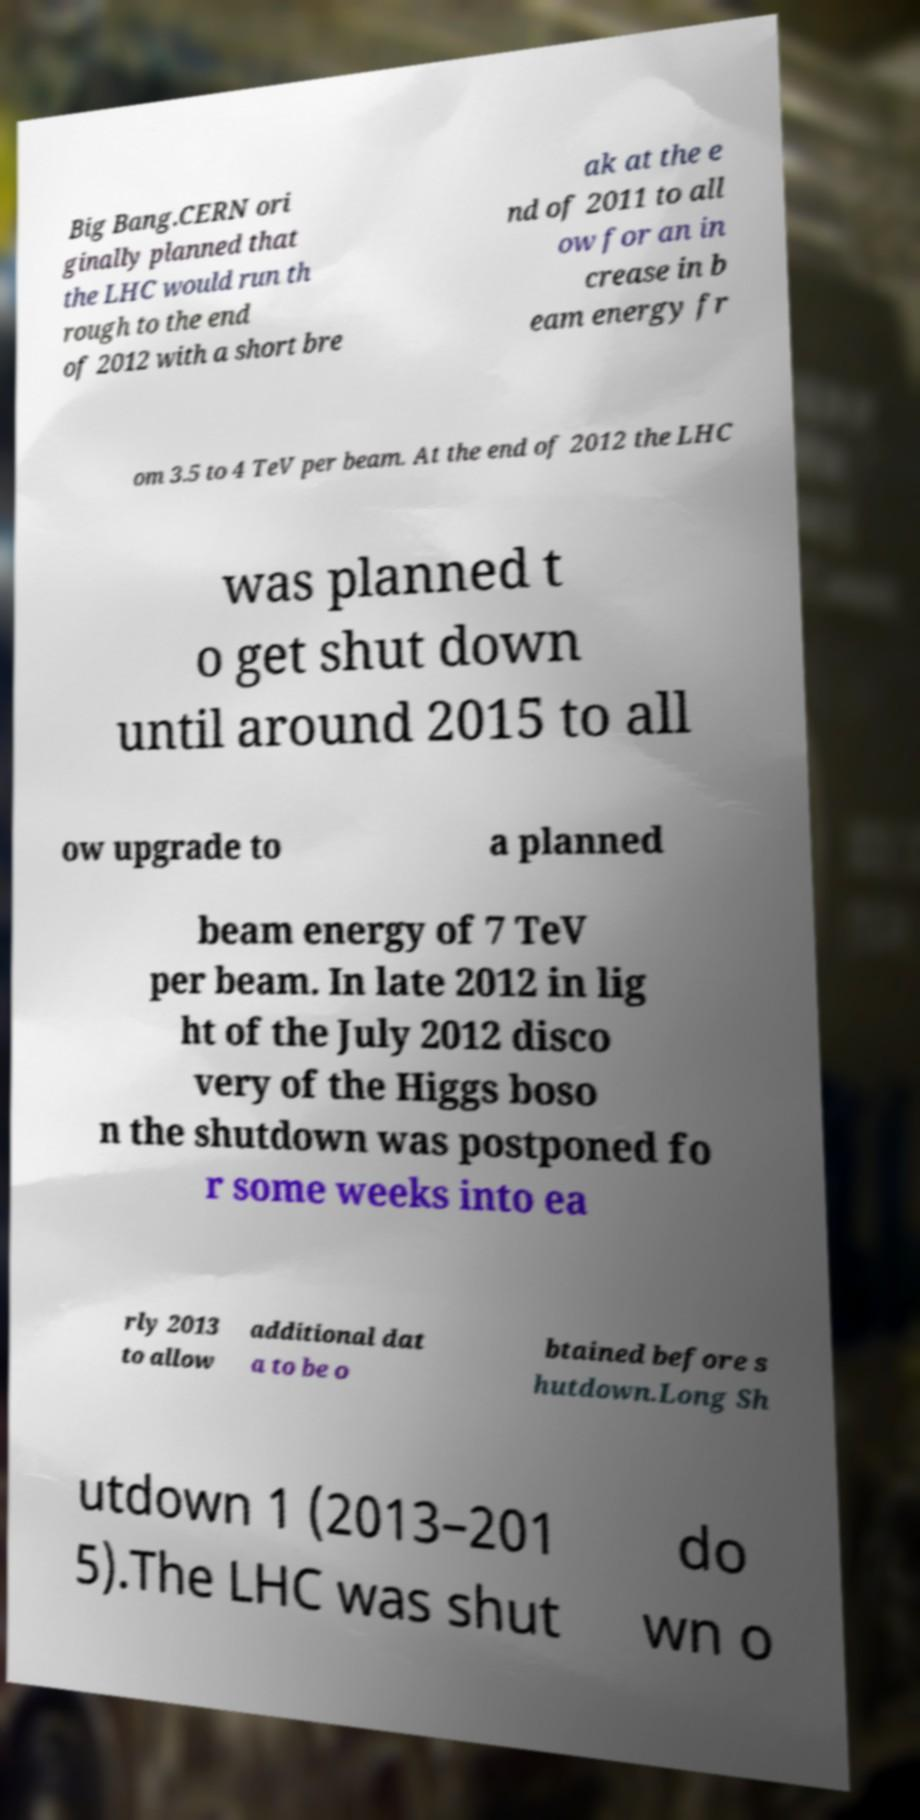What messages or text are displayed in this image? I need them in a readable, typed format. Big Bang.CERN ori ginally planned that the LHC would run th rough to the end of 2012 with a short bre ak at the e nd of 2011 to all ow for an in crease in b eam energy fr om 3.5 to 4 TeV per beam. At the end of 2012 the LHC was planned t o get shut down until around 2015 to all ow upgrade to a planned beam energy of 7 TeV per beam. In late 2012 in lig ht of the July 2012 disco very of the Higgs boso n the shutdown was postponed fo r some weeks into ea rly 2013 to allow additional dat a to be o btained before s hutdown.Long Sh utdown 1 (2013–201 5).The LHC was shut do wn o 